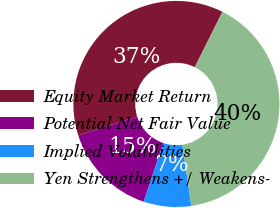Convert chart to OTSL. <chart><loc_0><loc_0><loc_500><loc_500><pie_chart><fcel>Equity Market Return<fcel>Potential Net Fair Value<fcel>Implied Volatilities<fcel>Yen Strengthens +/ Weakens-<nl><fcel>37.31%<fcel>14.93%<fcel>7.46%<fcel>40.3%<nl></chart> 